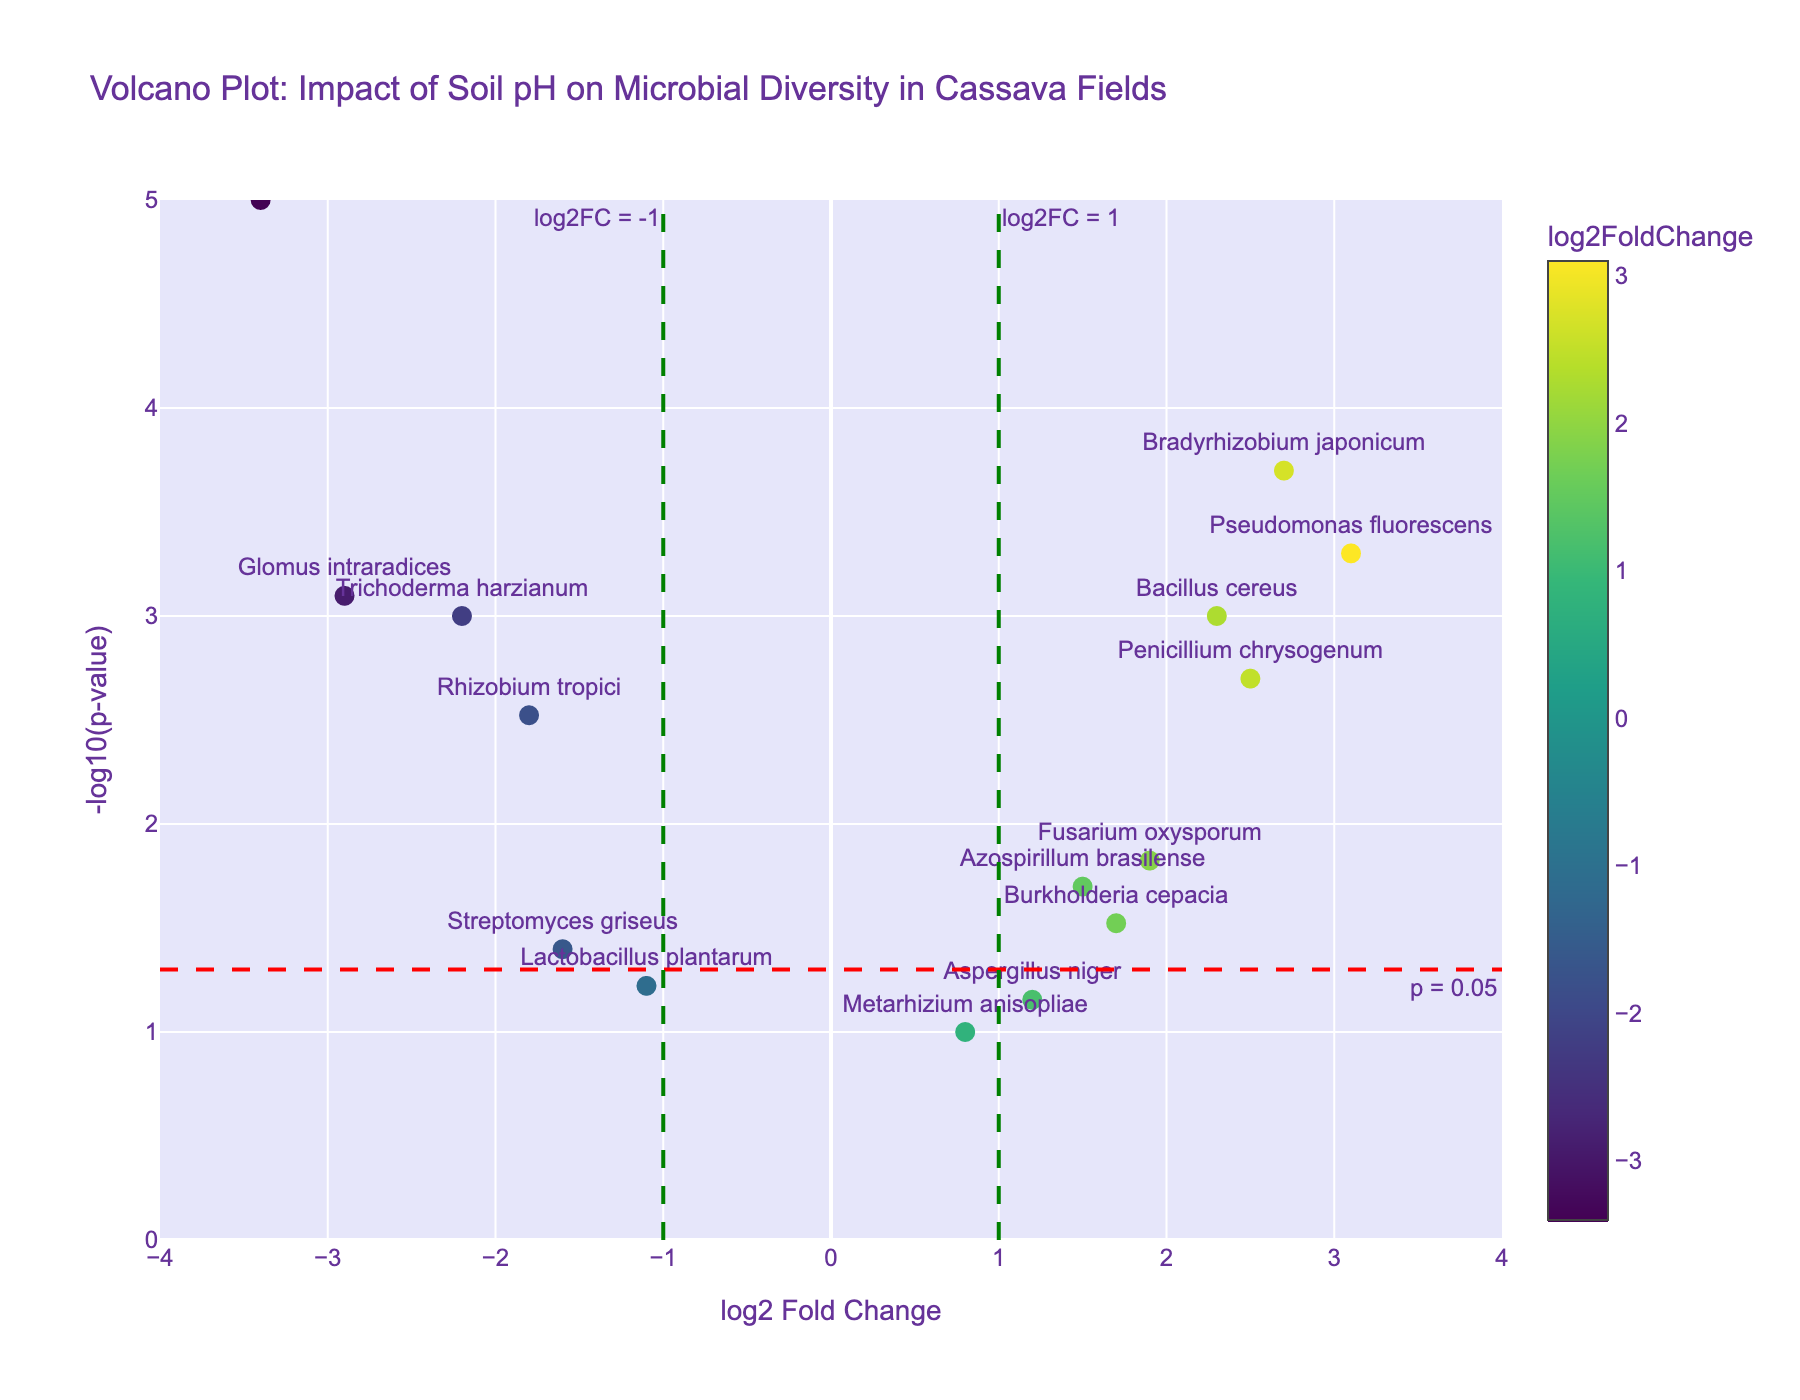How many data points are there in the figure? By counting the number of points (markers) visible in the plot, we can determine the total number of data points. There are 15 microbes listed in the data, so there should be 15 markers in the plot.
Answer: 15 What are the axes labels in the figure? The x-axis label is "log2 Fold Change" and the y-axis label is "-log10(p-value)". These labels are specified in the layout of the plot, describing the variables being plotted.
Answer: log2 Fold Change, -log10(p-value) Which microbial gene has the highest log2 fold change? By looking at the x-axis (log2 Fold Change) values, the point furthest to the right represents the highest log2 fold change. "Pseudomonas fluorescens" has the highest value of 3.1.
Answer: Pseudomonas fluorescens Which microbial gene has the lowest p-value? The point highest on the y-axis (-log10(p-value)) represents the smallest p-value. "Clostridium botulinum" has the highest -log10(p-value) value, indicating the lowest p-value.
Answer: Clostridium botulinum What is the significance threshold for p-value shown in the plot? A horizontal line is drawn at y = -log10(0.05). By calculating -log10(0.05), we find that the threshold corresponds to a value of approximately 1.3 on the y-axis.
Answer: 0.05 How many microbial genes have a log2 fold change greater than 1 and a significant p-value (p < 0.05)? Points need to be on the right side of the vertical line at x = 1 and above the horizontal line at y ≈ 1.3. Counting these points: "Pseudomonas fluorescens", "Bradyrhizobium japonicum", "Penicillium chrysogenum", "Bacillus cereus" and "Fusarium oxysporum". This totals to 5 genes.
Answer: 5 Which genes are downregulated (negative log2 fold change) and significant (p < 0.05)? Points need to be on the left side of the vertical line at x = -1 and above the horizontal line at y ≈ 1.3. Identifying these points gives: "Clostridium botulinum", "Glomus intraradices", "Trichoderma harzianum", and "Rhizobium tropici".
Answer: Clostridium botulinum, Glomus intraradices, Trichoderma harzianum, Rhizobium tropici What is the log2 fold change value for Bacillus cereus, and is it up or downregulated? Find "Bacillus cereus" on the plot and refer to the x-axis value. The log2 fold change for "Bacillus cereus" is 2.3, which is positive, indicating it is upregulated.
Answer: 2.3, upregulated Compare the log2 fold change of Rhizobium tropici and Bradyrhizobium japonicum. Which one is higher? By locating "Rhizobium tropici" and "Bradyrhizobium japonicum" on the plot, we can see that "Rhizobium tropici" has a log2 fold change of -1.8, and "Bradyrhizobium japonicum" has 2.7. Thus, Bradyrhizobium japonicum has a higher log2 fold change.
Answer: Bradyrhizobium japonicum 